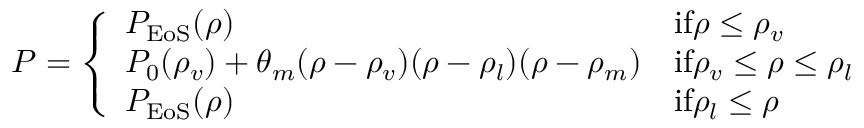Convert formula to latex. <formula><loc_0><loc_0><loc_500><loc_500>P = \left \{ \begin{array} { l l } { P _ { E o S } ( \rho ) } & { i f \rho \leq \rho _ { v } } \\ { P _ { 0 } ( \rho _ { v } ) + \theta _ { m } ( \rho - \rho _ { v } ) ( \rho - \rho _ { l } ) ( \rho - \rho _ { m } ) } & { i f \rho _ { v } \leq \rho \leq \rho _ { l } } \\ { P _ { E o S } ( \rho ) } & { i f \rho _ { l } \leq \rho } \end{array}</formula> 